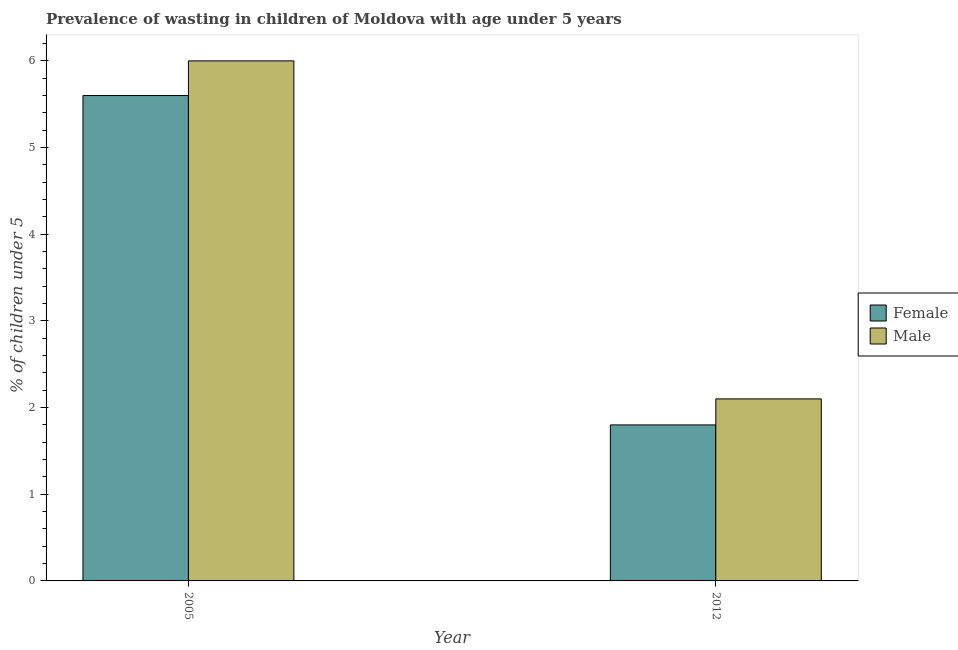How many different coloured bars are there?
Give a very brief answer. 2. Are the number of bars per tick equal to the number of legend labels?
Give a very brief answer. Yes. Are the number of bars on each tick of the X-axis equal?
Ensure brevity in your answer.  Yes. What is the label of the 1st group of bars from the left?
Your response must be concise. 2005. In how many cases, is the number of bars for a given year not equal to the number of legend labels?
Your answer should be compact. 0. Across all years, what is the maximum percentage of undernourished female children?
Keep it short and to the point. 5.6. Across all years, what is the minimum percentage of undernourished female children?
Offer a very short reply. 1.8. In which year was the percentage of undernourished female children maximum?
Offer a terse response. 2005. What is the total percentage of undernourished male children in the graph?
Provide a short and direct response. 8.1. What is the difference between the percentage of undernourished male children in 2005 and that in 2012?
Make the answer very short. 3.9. What is the difference between the percentage of undernourished female children in 2005 and the percentage of undernourished male children in 2012?
Your answer should be compact. 3.8. What is the average percentage of undernourished female children per year?
Your answer should be compact. 3.7. In how many years, is the percentage of undernourished female children greater than 4.8 %?
Your answer should be compact. 1. What is the ratio of the percentage of undernourished female children in 2005 to that in 2012?
Give a very brief answer. 3.11. In how many years, is the percentage of undernourished male children greater than the average percentage of undernourished male children taken over all years?
Provide a succinct answer. 1. How many bars are there?
Your answer should be very brief. 4. Are the values on the major ticks of Y-axis written in scientific E-notation?
Your answer should be very brief. No. Does the graph contain any zero values?
Offer a very short reply. No. How many legend labels are there?
Keep it short and to the point. 2. What is the title of the graph?
Your answer should be compact. Prevalence of wasting in children of Moldova with age under 5 years. What is the label or title of the X-axis?
Ensure brevity in your answer.  Year. What is the label or title of the Y-axis?
Make the answer very short.  % of children under 5. What is the  % of children under 5 of Female in 2005?
Make the answer very short. 5.6. What is the  % of children under 5 of Female in 2012?
Provide a short and direct response. 1.8. What is the  % of children under 5 in Male in 2012?
Your response must be concise. 2.1. Across all years, what is the maximum  % of children under 5 in Female?
Provide a succinct answer. 5.6. Across all years, what is the maximum  % of children under 5 of Male?
Your answer should be very brief. 6. Across all years, what is the minimum  % of children under 5 in Female?
Your answer should be compact. 1.8. Across all years, what is the minimum  % of children under 5 in Male?
Keep it short and to the point. 2.1. What is the total  % of children under 5 of Male in the graph?
Offer a terse response. 8.1. What is the difference between the  % of children under 5 in Female in 2005 and that in 2012?
Ensure brevity in your answer.  3.8. What is the difference between the  % of children under 5 in Male in 2005 and that in 2012?
Ensure brevity in your answer.  3.9. What is the difference between the  % of children under 5 in Female in 2005 and the  % of children under 5 in Male in 2012?
Provide a succinct answer. 3.5. What is the average  % of children under 5 of Male per year?
Offer a very short reply. 4.05. In the year 2005, what is the difference between the  % of children under 5 in Female and  % of children under 5 in Male?
Offer a terse response. -0.4. What is the ratio of the  % of children under 5 of Female in 2005 to that in 2012?
Ensure brevity in your answer.  3.11. What is the ratio of the  % of children under 5 in Male in 2005 to that in 2012?
Your answer should be compact. 2.86. What is the difference between the highest and the second highest  % of children under 5 in Female?
Ensure brevity in your answer.  3.8. What is the difference between the highest and the second highest  % of children under 5 of Male?
Offer a very short reply. 3.9. What is the difference between the highest and the lowest  % of children under 5 in Female?
Offer a terse response. 3.8. 